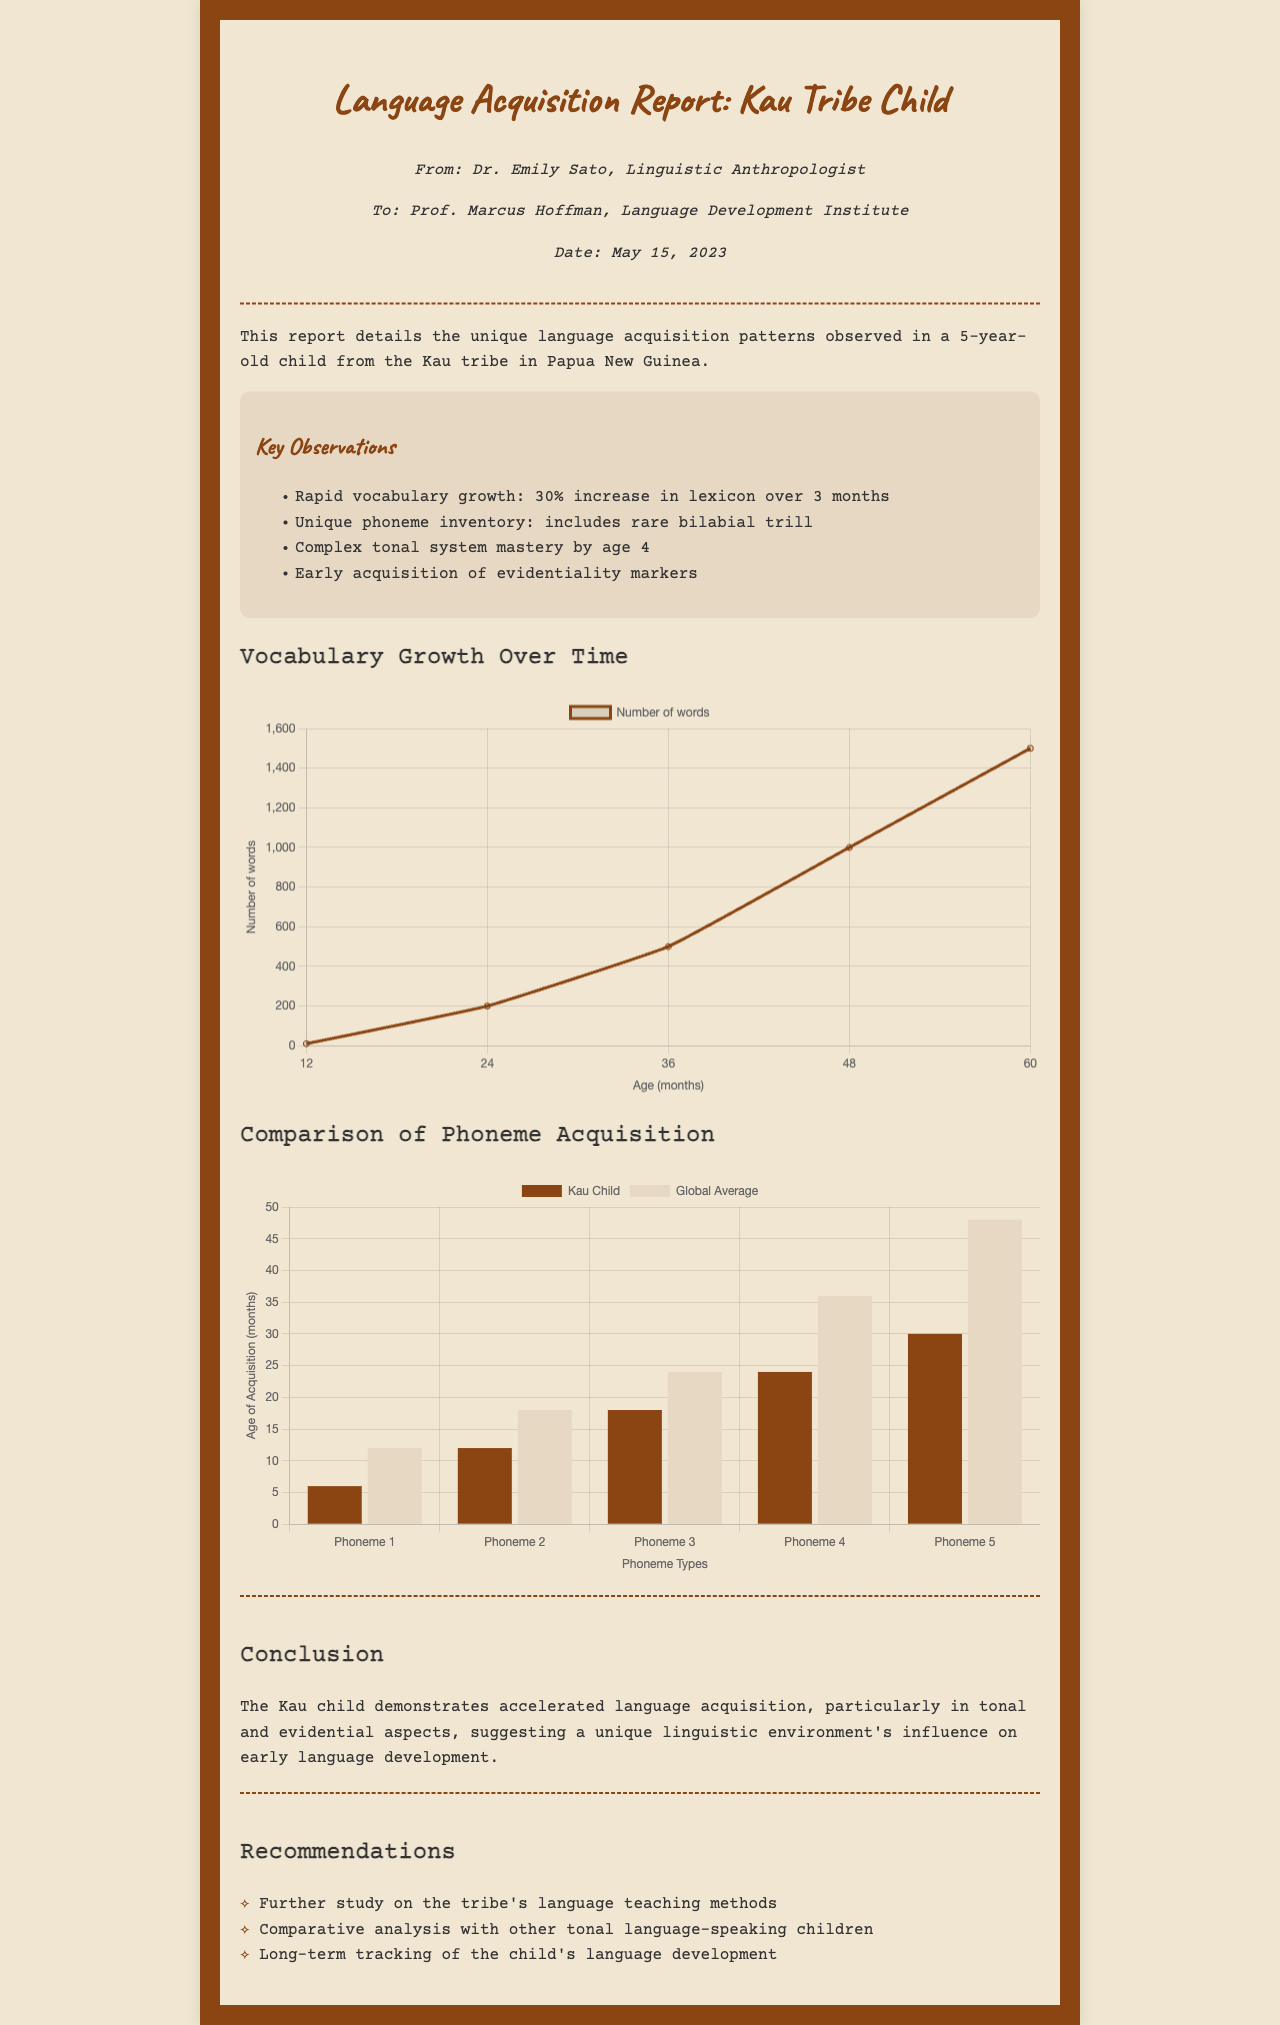What is the age of the child observed? The child observed in the report is stated to be 5 years old.
Answer: 5 years old What unique phoneme is noted in the report? The report mentions the child's unique phoneme inventory which includes a rare bilabial trill.
Answer: bilabial trill How much did the vocabulary increase over three months? The report specifies a 30% increase in the child's vocabulary over a span of three months.
Answer: 30% What is the title of the document? The title of the document is explicitly stated at the top of the report.
Answer: Language Acquisition Report: Kau Tribe Child Who authored the report? The sender of the report is Dr. Emily Sato, a linguistic anthropologist as noted in the sender's information.
Answer: Dr. Emily Sato Which tonal aspect did the child master by age 4? It is noted that the child mastered the complex tonal system by the time they were four years old.
Answer: complex tonal system What does the conclusion suggest about the child's language development? The conclusion states that the Kau child demonstrates accelerated language acquisition, influenced by their unique linguistic environment.
Answer: accelerated language acquisition What type of analysis is recommended in the document? The document recommends conducting a comparative analysis with other tonal language-speaking children.
Answer: comparative analysis 